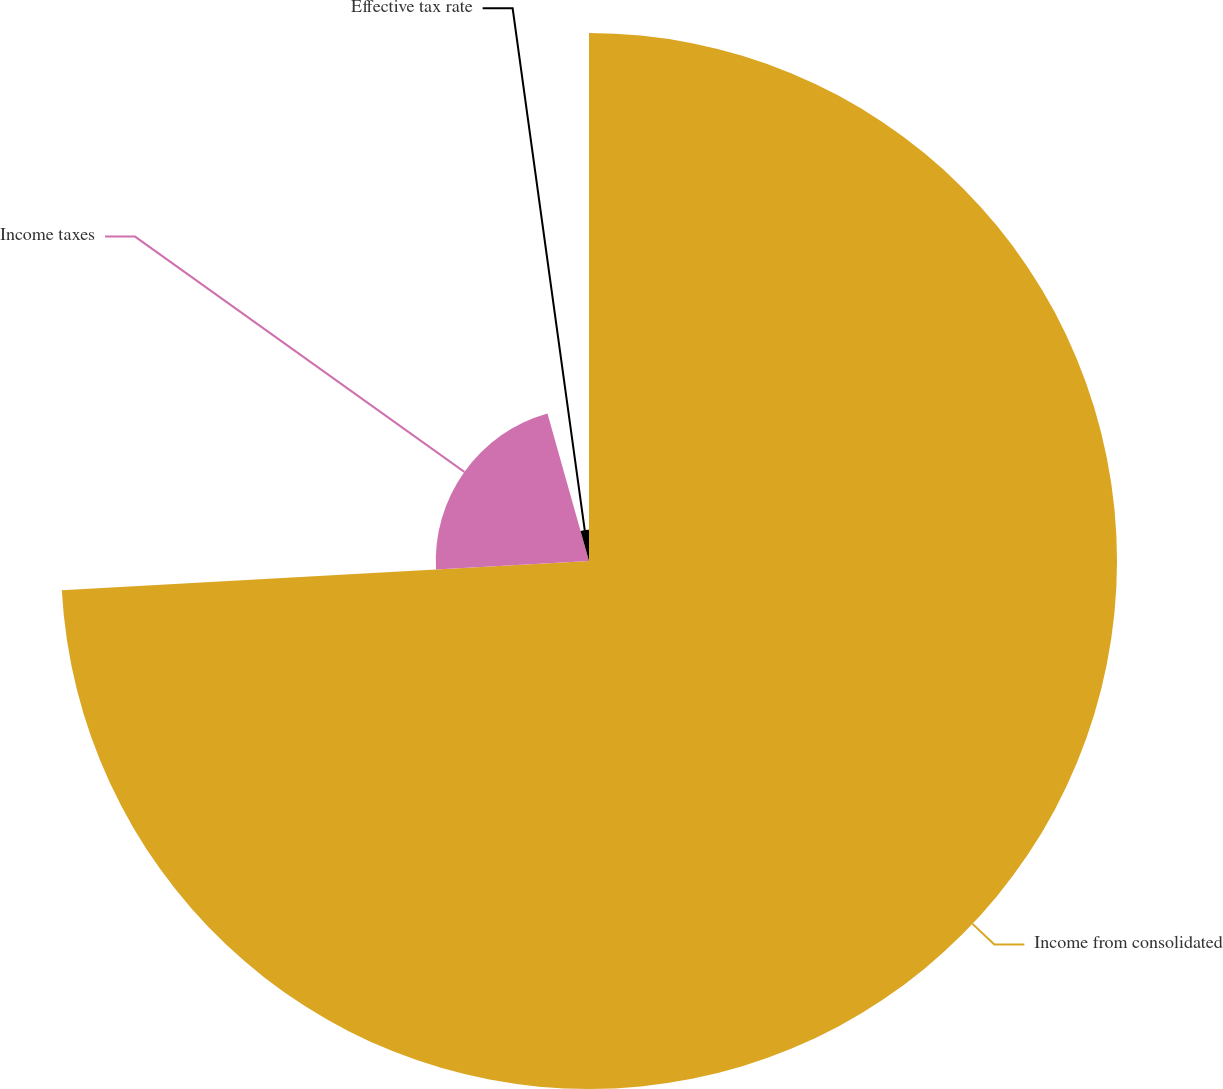Convert chart to OTSL. <chart><loc_0><loc_0><loc_500><loc_500><pie_chart><fcel>Income from consolidated<fcel>Income taxes<fcel>Effective tax rate<nl><fcel>74.12%<fcel>21.51%<fcel>4.37%<nl></chart> 